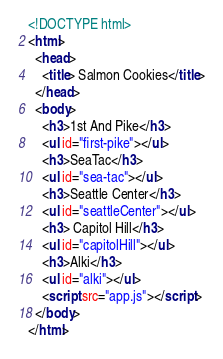<code> <loc_0><loc_0><loc_500><loc_500><_HTML_><!DOCTYPE html>
<html>
  <head>
    <title> Salmon Cookies</title>
  </head>
  <body>
    <h3>1st And Pike</h3>
    <ul id="first-pike"></ul>
    <h3>SeaTac</h3>
    <ul id="sea-tac"></ul>
    <h3>Seattle Center</h3>
    <ul id="seattleCenter"></ul>
    <h3> Capitol Hill</h3>
    <ul id="capitolHill"></ul>
    <h3>Alki</h3>
    <ul id="alki"></ul>
    <script src="app.js"></script>
  </body>
</html></code> 